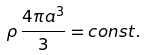Convert formula to latex. <formula><loc_0><loc_0><loc_500><loc_500>\rho \, \frac { 4 \pi a ^ { 3 } } { 3 } = c o n s t .</formula> 